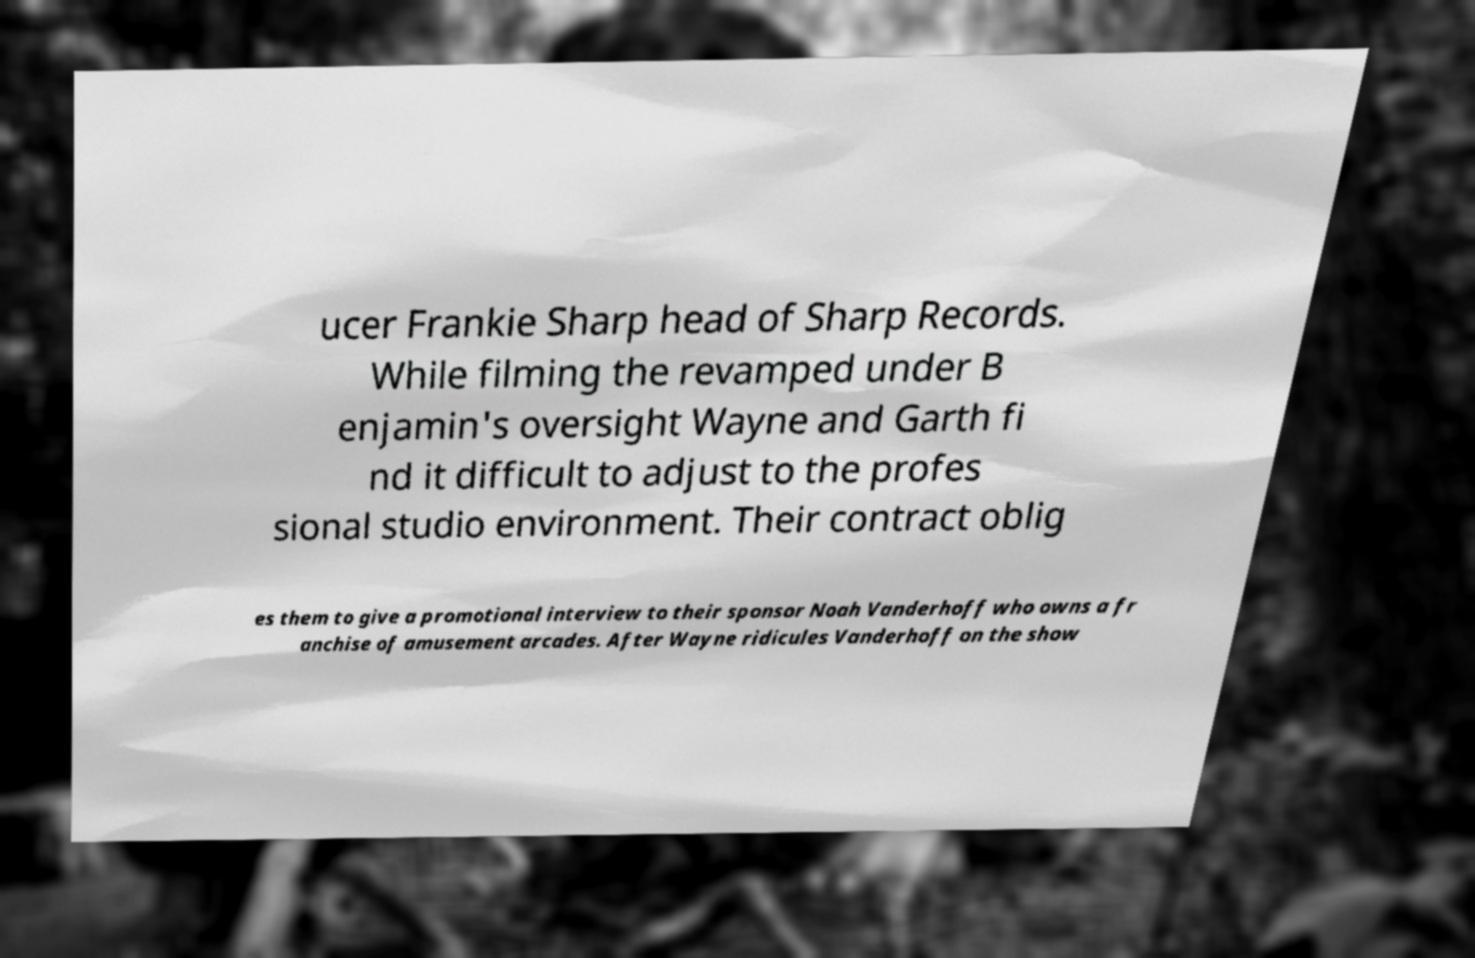Can you read and provide the text displayed in the image?This photo seems to have some interesting text. Can you extract and type it out for me? ucer Frankie Sharp head of Sharp Records. While filming the revamped under B enjamin's oversight Wayne and Garth fi nd it difficult to adjust to the profes sional studio environment. Their contract oblig es them to give a promotional interview to their sponsor Noah Vanderhoff who owns a fr anchise of amusement arcades. After Wayne ridicules Vanderhoff on the show 